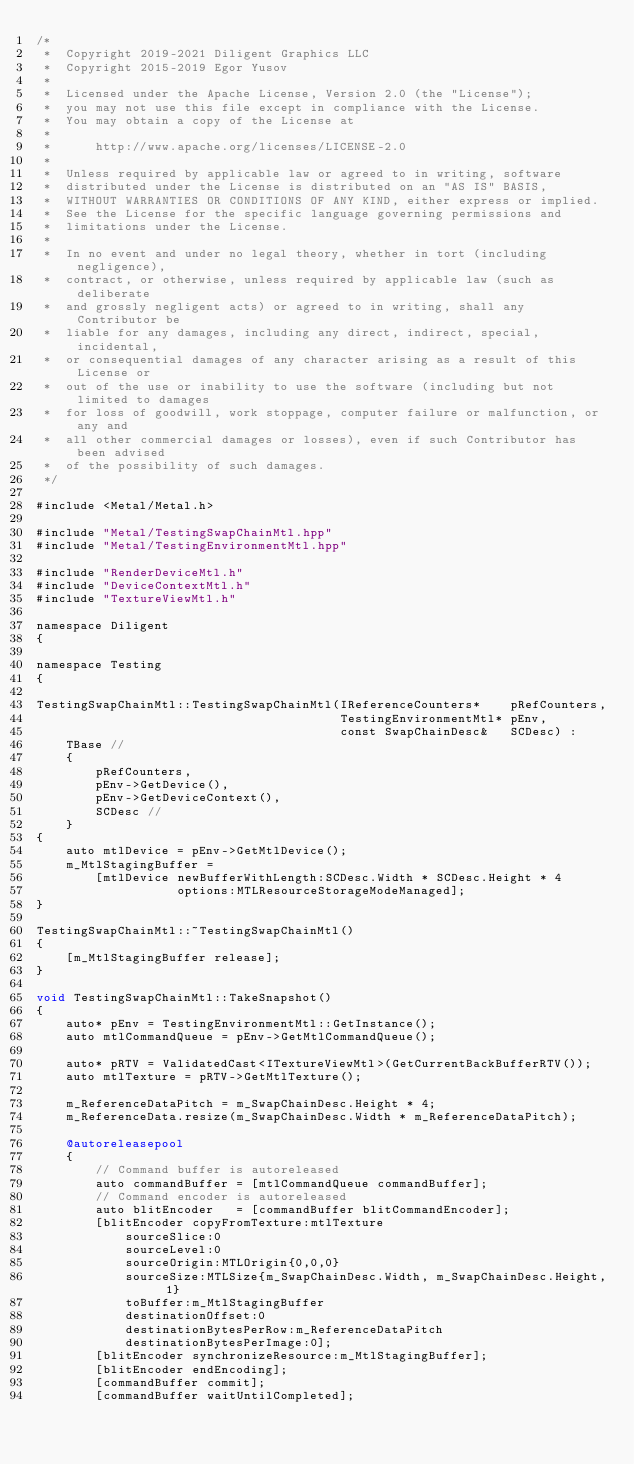Convert code to text. <code><loc_0><loc_0><loc_500><loc_500><_ObjectiveC_>/*
 *  Copyright 2019-2021 Diligent Graphics LLC
 *  Copyright 2015-2019 Egor Yusov
 *  
 *  Licensed under the Apache License, Version 2.0 (the "License");
 *  you may not use this file except in compliance with the License.
 *  You may obtain a copy of the License at
 *  
 *      http://www.apache.org/licenses/LICENSE-2.0
 *  
 *  Unless required by applicable law or agreed to in writing, software
 *  distributed under the License is distributed on an "AS IS" BASIS,
 *  WITHOUT WARRANTIES OR CONDITIONS OF ANY KIND, either express or implied.
 *  See the License for the specific language governing permissions and
 *  limitations under the License.
 *
 *  In no event and under no legal theory, whether in tort (including negligence), 
 *  contract, or otherwise, unless required by applicable law (such as deliberate 
 *  and grossly negligent acts) or agreed to in writing, shall any Contributor be
 *  liable for any damages, including any direct, indirect, special, incidental, 
 *  or consequential damages of any character arising as a result of this License or 
 *  out of the use or inability to use the software (including but not limited to damages 
 *  for loss of goodwill, work stoppage, computer failure or malfunction, or any and 
 *  all other commercial damages or losses), even if such Contributor has been advised 
 *  of the possibility of such damages.
 */

#include <Metal/Metal.h>

#include "Metal/TestingSwapChainMtl.hpp"
#include "Metal/TestingEnvironmentMtl.hpp"

#include "RenderDeviceMtl.h"
#include "DeviceContextMtl.h"
#include "TextureViewMtl.h"

namespace Diligent
{

namespace Testing
{

TestingSwapChainMtl::TestingSwapChainMtl(IReferenceCounters*    pRefCounters,
                                         TestingEnvironmentMtl* pEnv,
                                         const SwapChainDesc&   SCDesc) :
    TBase //
    {
        pRefCounters,
        pEnv->GetDevice(),
        pEnv->GetDeviceContext(),
        SCDesc //
    }
{
    auto mtlDevice = pEnv->GetMtlDevice();
    m_MtlStagingBuffer =
        [mtlDevice newBufferWithLength:SCDesc.Width * SCDesc.Height * 4
                   options:MTLResourceStorageModeManaged];
}

TestingSwapChainMtl::~TestingSwapChainMtl()
{
    [m_MtlStagingBuffer release];
}

void TestingSwapChainMtl::TakeSnapshot()
{
    auto* pEnv = TestingEnvironmentMtl::GetInstance();
    auto mtlCommandQueue = pEnv->GetMtlCommandQueue();

    auto* pRTV = ValidatedCast<ITextureViewMtl>(GetCurrentBackBufferRTV());
    auto mtlTexture = pRTV->GetMtlTexture();

    m_ReferenceDataPitch = m_SwapChainDesc.Height * 4;
    m_ReferenceData.resize(m_SwapChainDesc.Width * m_ReferenceDataPitch);

    @autoreleasepool
    {
        // Command buffer is autoreleased
        auto commandBuffer = [mtlCommandQueue commandBuffer];
        // Command encoder is autoreleased
        auto blitEncoder   = [commandBuffer blitCommandEncoder];
        [blitEncoder copyFromTexture:mtlTexture
            sourceSlice:0
            sourceLevel:0
            sourceOrigin:MTLOrigin{0,0,0}
            sourceSize:MTLSize{m_SwapChainDesc.Width, m_SwapChainDesc.Height, 1}
            toBuffer:m_MtlStagingBuffer
            destinationOffset:0
            destinationBytesPerRow:m_ReferenceDataPitch
            destinationBytesPerImage:0];
        [blitEncoder synchronizeResource:m_MtlStagingBuffer];
        [blitEncoder endEncoding];
        [commandBuffer commit];
        [commandBuffer waitUntilCompleted];</code> 